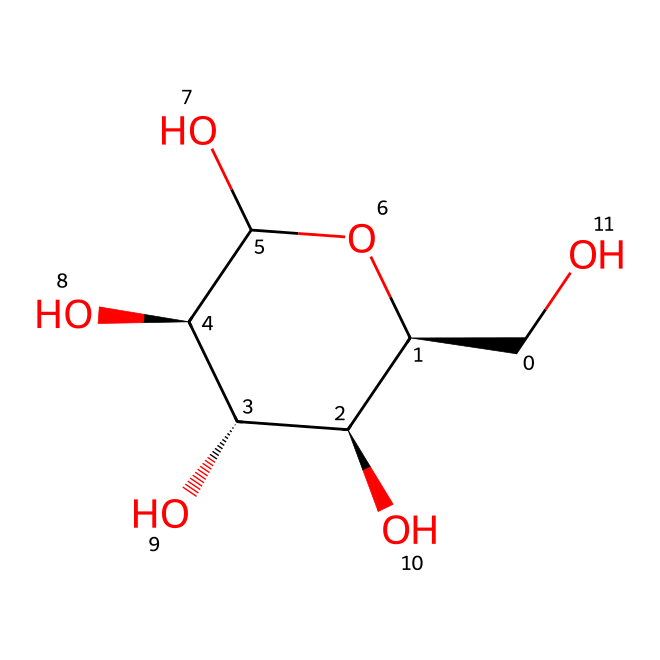What is the primary monosaccharide unit in cellulose? Cellulose is a polysaccharide composed of beta-D-glucose units linked by glycosidic bonds. Each unit represents the repeating structure.
Answer: beta-D-glucose How many hydroxyl groups are present in this molecule? In the chemical representation, each carbon atom in the structure (excluding the carbon in the ring) has a hydroxyl group attached. Counting these groups, there are four hydroxyl groups.
Answer: four What type of linkage connects the glucose units in cellulose? The glucose units in cellulose are linked together by beta-1,4-glycosidic bonds, which can be identified through their configuration and positions in the chain.
Answer: beta-1,4-glycosidic What is the approximate molecular weight of cellulose based on the given SMILES? To find the molecular weight, we can calculate the total number of carbon, hydrogen, and oxygen atoms indicated in the SMILES and use their atomic weights (approximately 12, 1, and 16 g/mol, respectively). The molecular weight of the simplified unit shown is roughly 162 g/mol.
Answer: 162 How does the structure of cellulose contribute to its strength? The linear arrangement of the glucose units and the extensive hydrogen bonding between chains provide structural rigidity and tensile strength, allowing cellulose to be an essential component in wound dressings.
Answer: hydrogen bonding What functional groups are predominantly present in cellulose? The structure predominantly contains hydroxyl (-OH) groups, which are responsible for the hydrophilic nature of cellulose and its interactions with water.
Answer: hydroxyl groups 